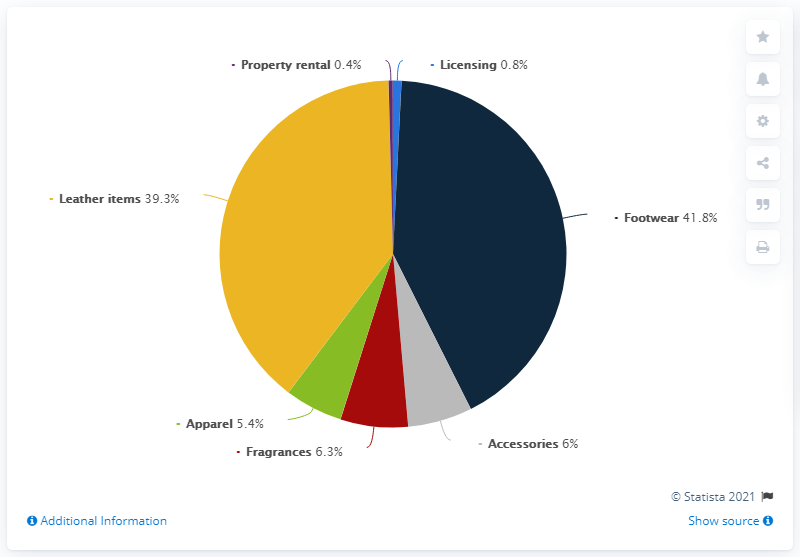Draw attention to some important aspects in this diagram. No category has reached 50% or more. The combined sales of fragrances and accessories accounted for approximately 12.3% of the company's total revenues in the given period. 